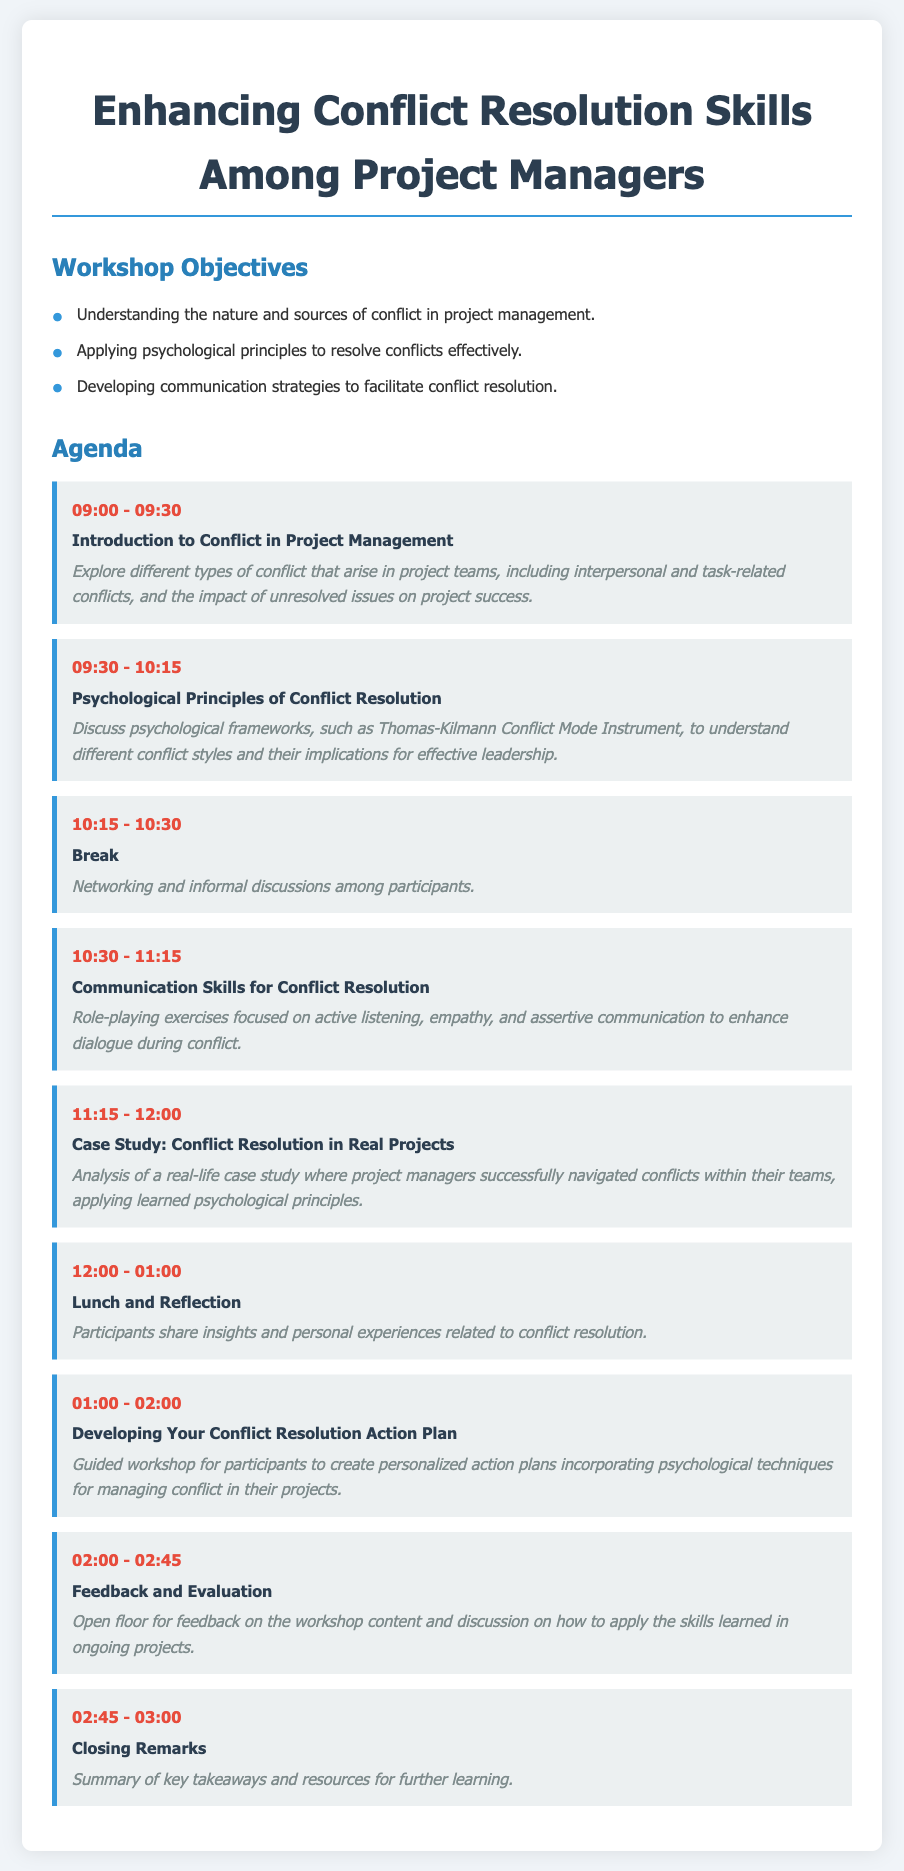What is the duration of the workshop? The duration of the workshop is defined by the start and end times of the agenda items, spanning from 09:00 to 03:00, which totals 6 hours.
Answer: 6 hours What time does the "Communication Skills for Conflict Resolution" session start? This session starts at 10:30 according to the agenda.
Answer: 10:30 Which psychological framework is mentioned in the agenda? The agenda specifically mentions the Thomas-Kilmann Conflict Mode Instrument as a psychological framework for understanding conflict styles.
Answer: Thomas-Kilmann Conflict Mode Instrument How long is the break scheduled for? The break is scheduled for 15 minutes, from 10:15 to 10:30.
Answer: 15 minutes What topic is discussed during the 01:00 - 02:00 session? This session focuses on developing personalized action plans for managing conflict.
Answer: Developing Your Conflict Resolution Action Plan Which session includes role-playing exercises? The session titled "Communication Skills for Conflict Resolution" includes role-playing exercises.
Answer: Communication Skills for Conflict Resolution What is the main focus of the workshop? The primary focus of the workshop is on enhancing conflict resolution skills among project managers.
Answer: Enhancing conflict resolution skills When is the "Feedback and Evaluation" session scheduled? This session is scheduled from 02:00 to 02:45.
Answer: 02:00 - 02:45 What is the content of the "Case Study" session? The content of this session involves analyzing a real-life case study related to conflict resolution in projects.
Answer: Analysis of a real-life case study 